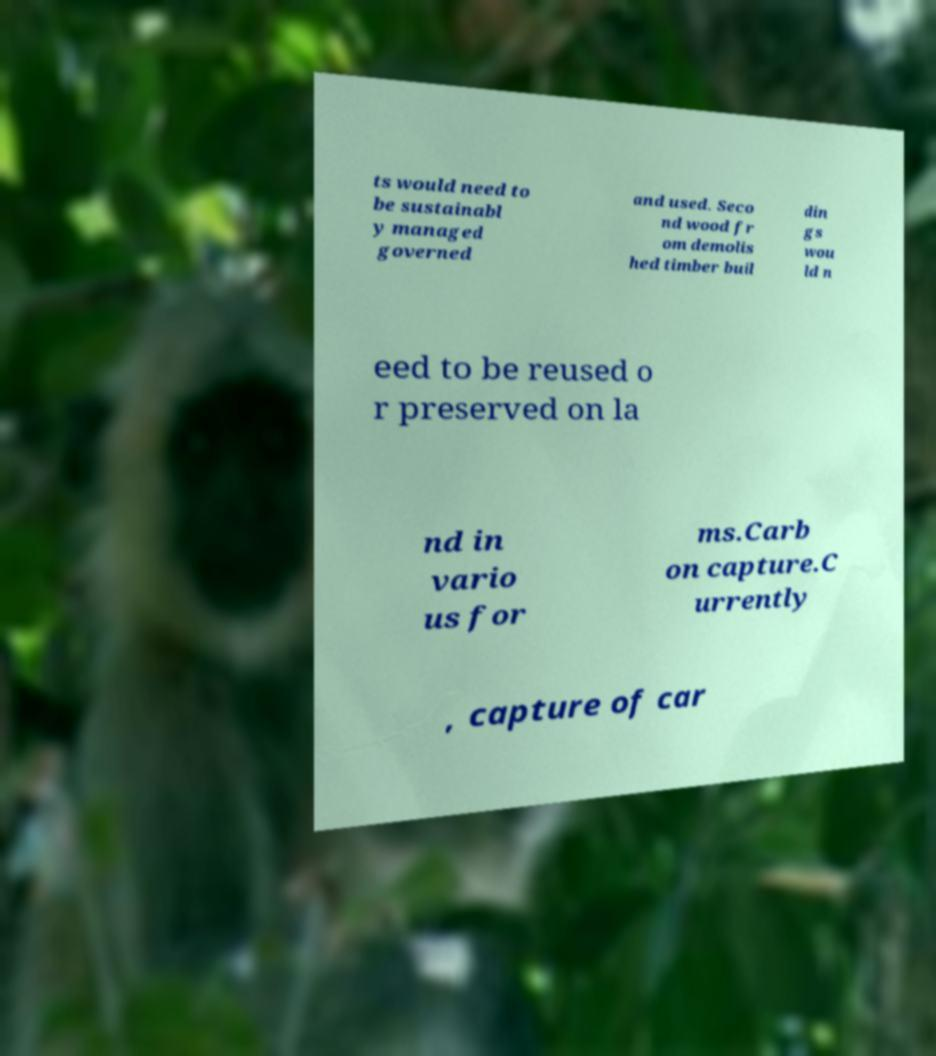I need the written content from this picture converted into text. Can you do that? ts would need to be sustainabl y managed governed and used. Seco nd wood fr om demolis hed timber buil din gs wou ld n eed to be reused o r preserved on la nd in vario us for ms.Carb on capture.C urrently , capture of car 